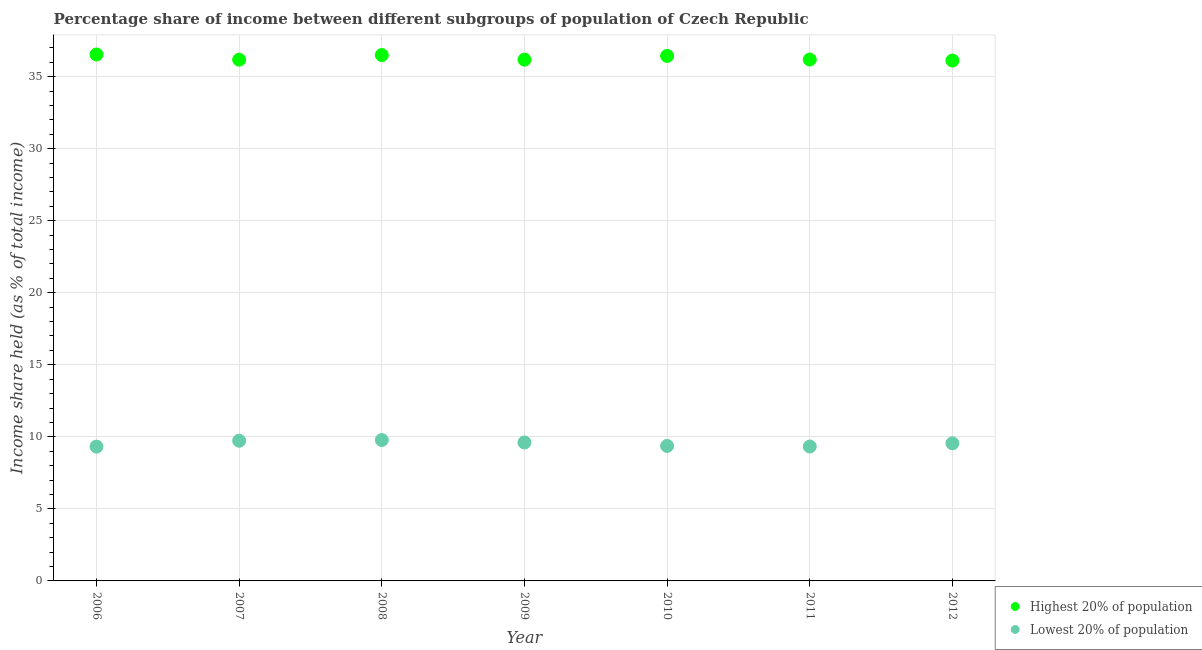Is the number of dotlines equal to the number of legend labels?
Your answer should be very brief. Yes. What is the income share held by highest 20% of the population in 2012?
Offer a terse response. 36.12. Across all years, what is the maximum income share held by lowest 20% of the population?
Keep it short and to the point. 9.78. Across all years, what is the minimum income share held by lowest 20% of the population?
Provide a short and direct response. 9.32. What is the total income share held by highest 20% of the population in the graph?
Your response must be concise. 254.15. What is the difference between the income share held by highest 20% of the population in 2007 and that in 2011?
Provide a short and direct response. -0.01. What is the difference between the income share held by highest 20% of the population in 2011 and the income share held by lowest 20% of the population in 2006?
Give a very brief answer. 26.87. What is the average income share held by highest 20% of the population per year?
Your answer should be compact. 36.31. In the year 2012, what is the difference between the income share held by highest 20% of the population and income share held by lowest 20% of the population?
Keep it short and to the point. 26.57. What is the ratio of the income share held by highest 20% of the population in 2009 to that in 2011?
Keep it short and to the point. 1. Is the difference between the income share held by lowest 20% of the population in 2011 and 2012 greater than the difference between the income share held by highest 20% of the population in 2011 and 2012?
Offer a very short reply. No. What is the difference between the highest and the second highest income share held by highest 20% of the population?
Your answer should be very brief. 0.04. What is the difference between the highest and the lowest income share held by highest 20% of the population?
Provide a short and direct response. 0.42. In how many years, is the income share held by lowest 20% of the population greater than the average income share held by lowest 20% of the population taken over all years?
Keep it short and to the point. 4. Does the income share held by highest 20% of the population monotonically increase over the years?
Ensure brevity in your answer.  No. Is the income share held by lowest 20% of the population strictly greater than the income share held by highest 20% of the population over the years?
Provide a succinct answer. No. How many dotlines are there?
Give a very brief answer. 2. How many years are there in the graph?
Give a very brief answer. 7. Are the values on the major ticks of Y-axis written in scientific E-notation?
Give a very brief answer. No. Does the graph contain any zero values?
Offer a very short reply. No. Where does the legend appear in the graph?
Provide a short and direct response. Bottom right. How many legend labels are there?
Your answer should be very brief. 2. How are the legend labels stacked?
Provide a short and direct response. Vertical. What is the title of the graph?
Provide a succinct answer. Percentage share of income between different subgroups of population of Czech Republic. Does "Electricity and heat production" appear as one of the legend labels in the graph?
Ensure brevity in your answer.  No. What is the label or title of the X-axis?
Keep it short and to the point. Year. What is the label or title of the Y-axis?
Your answer should be compact. Income share held (as % of total income). What is the Income share held (as % of total income) of Highest 20% of population in 2006?
Offer a terse response. 36.54. What is the Income share held (as % of total income) in Lowest 20% of population in 2006?
Provide a short and direct response. 9.32. What is the Income share held (as % of total income) in Highest 20% of population in 2007?
Your answer should be compact. 36.18. What is the Income share held (as % of total income) in Lowest 20% of population in 2007?
Make the answer very short. 9.73. What is the Income share held (as % of total income) in Highest 20% of population in 2008?
Provide a succinct answer. 36.5. What is the Income share held (as % of total income) in Lowest 20% of population in 2008?
Offer a terse response. 9.78. What is the Income share held (as % of total income) of Highest 20% of population in 2009?
Make the answer very short. 36.18. What is the Income share held (as % of total income) in Lowest 20% of population in 2009?
Your response must be concise. 9.61. What is the Income share held (as % of total income) in Highest 20% of population in 2010?
Offer a terse response. 36.44. What is the Income share held (as % of total income) of Lowest 20% of population in 2010?
Your answer should be compact. 9.37. What is the Income share held (as % of total income) of Highest 20% of population in 2011?
Ensure brevity in your answer.  36.19. What is the Income share held (as % of total income) in Lowest 20% of population in 2011?
Provide a succinct answer. 9.33. What is the Income share held (as % of total income) in Highest 20% of population in 2012?
Give a very brief answer. 36.12. What is the Income share held (as % of total income) in Lowest 20% of population in 2012?
Provide a succinct answer. 9.55. Across all years, what is the maximum Income share held (as % of total income) in Highest 20% of population?
Make the answer very short. 36.54. Across all years, what is the maximum Income share held (as % of total income) of Lowest 20% of population?
Provide a short and direct response. 9.78. Across all years, what is the minimum Income share held (as % of total income) in Highest 20% of population?
Your answer should be compact. 36.12. Across all years, what is the minimum Income share held (as % of total income) of Lowest 20% of population?
Your answer should be very brief. 9.32. What is the total Income share held (as % of total income) of Highest 20% of population in the graph?
Provide a succinct answer. 254.15. What is the total Income share held (as % of total income) of Lowest 20% of population in the graph?
Ensure brevity in your answer.  66.69. What is the difference between the Income share held (as % of total income) in Highest 20% of population in 2006 and that in 2007?
Make the answer very short. 0.36. What is the difference between the Income share held (as % of total income) in Lowest 20% of population in 2006 and that in 2007?
Your answer should be compact. -0.41. What is the difference between the Income share held (as % of total income) of Lowest 20% of population in 2006 and that in 2008?
Your answer should be compact. -0.46. What is the difference between the Income share held (as % of total income) of Highest 20% of population in 2006 and that in 2009?
Keep it short and to the point. 0.36. What is the difference between the Income share held (as % of total income) of Lowest 20% of population in 2006 and that in 2009?
Ensure brevity in your answer.  -0.29. What is the difference between the Income share held (as % of total income) in Lowest 20% of population in 2006 and that in 2011?
Your response must be concise. -0.01. What is the difference between the Income share held (as % of total income) in Highest 20% of population in 2006 and that in 2012?
Give a very brief answer. 0.42. What is the difference between the Income share held (as % of total income) of Lowest 20% of population in 2006 and that in 2012?
Give a very brief answer. -0.23. What is the difference between the Income share held (as % of total income) of Highest 20% of population in 2007 and that in 2008?
Keep it short and to the point. -0.32. What is the difference between the Income share held (as % of total income) of Lowest 20% of population in 2007 and that in 2008?
Keep it short and to the point. -0.05. What is the difference between the Income share held (as % of total income) of Highest 20% of population in 2007 and that in 2009?
Your answer should be very brief. 0. What is the difference between the Income share held (as % of total income) in Lowest 20% of population in 2007 and that in 2009?
Keep it short and to the point. 0.12. What is the difference between the Income share held (as % of total income) in Highest 20% of population in 2007 and that in 2010?
Offer a very short reply. -0.26. What is the difference between the Income share held (as % of total income) in Lowest 20% of population in 2007 and that in 2010?
Provide a short and direct response. 0.36. What is the difference between the Income share held (as % of total income) in Highest 20% of population in 2007 and that in 2011?
Offer a terse response. -0.01. What is the difference between the Income share held (as % of total income) in Highest 20% of population in 2007 and that in 2012?
Give a very brief answer. 0.06. What is the difference between the Income share held (as % of total income) of Lowest 20% of population in 2007 and that in 2012?
Give a very brief answer. 0.18. What is the difference between the Income share held (as % of total income) of Highest 20% of population in 2008 and that in 2009?
Your answer should be compact. 0.32. What is the difference between the Income share held (as % of total income) in Lowest 20% of population in 2008 and that in 2009?
Provide a short and direct response. 0.17. What is the difference between the Income share held (as % of total income) of Highest 20% of population in 2008 and that in 2010?
Offer a very short reply. 0.06. What is the difference between the Income share held (as % of total income) in Lowest 20% of population in 2008 and that in 2010?
Your answer should be very brief. 0.41. What is the difference between the Income share held (as % of total income) of Highest 20% of population in 2008 and that in 2011?
Provide a short and direct response. 0.31. What is the difference between the Income share held (as % of total income) in Lowest 20% of population in 2008 and that in 2011?
Give a very brief answer. 0.45. What is the difference between the Income share held (as % of total income) of Highest 20% of population in 2008 and that in 2012?
Offer a very short reply. 0.38. What is the difference between the Income share held (as % of total income) of Lowest 20% of population in 2008 and that in 2012?
Offer a terse response. 0.23. What is the difference between the Income share held (as % of total income) of Highest 20% of population in 2009 and that in 2010?
Keep it short and to the point. -0.26. What is the difference between the Income share held (as % of total income) in Lowest 20% of population in 2009 and that in 2010?
Ensure brevity in your answer.  0.24. What is the difference between the Income share held (as % of total income) in Highest 20% of population in 2009 and that in 2011?
Give a very brief answer. -0.01. What is the difference between the Income share held (as % of total income) of Lowest 20% of population in 2009 and that in 2011?
Make the answer very short. 0.28. What is the difference between the Income share held (as % of total income) of Lowest 20% of population in 2010 and that in 2011?
Offer a terse response. 0.04. What is the difference between the Income share held (as % of total income) of Highest 20% of population in 2010 and that in 2012?
Offer a very short reply. 0.32. What is the difference between the Income share held (as % of total income) in Lowest 20% of population in 2010 and that in 2012?
Make the answer very short. -0.18. What is the difference between the Income share held (as % of total income) in Highest 20% of population in 2011 and that in 2012?
Provide a succinct answer. 0.07. What is the difference between the Income share held (as % of total income) of Lowest 20% of population in 2011 and that in 2012?
Give a very brief answer. -0.22. What is the difference between the Income share held (as % of total income) in Highest 20% of population in 2006 and the Income share held (as % of total income) in Lowest 20% of population in 2007?
Your response must be concise. 26.81. What is the difference between the Income share held (as % of total income) of Highest 20% of population in 2006 and the Income share held (as % of total income) of Lowest 20% of population in 2008?
Offer a terse response. 26.76. What is the difference between the Income share held (as % of total income) in Highest 20% of population in 2006 and the Income share held (as % of total income) in Lowest 20% of population in 2009?
Give a very brief answer. 26.93. What is the difference between the Income share held (as % of total income) of Highest 20% of population in 2006 and the Income share held (as % of total income) of Lowest 20% of population in 2010?
Your answer should be very brief. 27.17. What is the difference between the Income share held (as % of total income) of Highest 20% of population in 2006 and the Income share held (as % of total income) of Lowest 20% of population in 2011?
Provide a short and direct response. 27.21. What is the difference between the Income share held (as % of total income) in Highest 20% of population in 2006 and the Income share held (as % of total income) in Lowest 20% of population in 2012?
Offer a very short reply. 26.99. What is the difference between the Income share held (as % of total income) in Highest 20% of population in 2007 and the Income share held (as % of total income) in Lowest 20% of population in 2008?
Give a very brief answer. 26.4. What is the difference between the Income share held (as % of total income) of Highest 20% of population in 2007 and the Income share held (as % of total income) of Lowest 20% of population in 2009?
Provide a short and direct response. 26.57. What is the difference between the Income share held (as % of total income) in Highest 20% of population in 2007 and the Income share held (as % of total income) in Lowest 20% of population in 2010?
Make the answer very short. 26.81. What is the difference between the Income share held (as % of total income) in Highest 20% of population in 2007 and the Income share held (as % of total income) in Lowest 20% of population in 2011?
Offer a very short reply. 26.85. What is the difference between the Income share held (as % of total income) in Highest 20% of population in 2007 and the Income share held (as % of total income) in Lowest 20% of population in 2012?
Your response must be concise. 26.63. What is the difference between the Income share held (as % of total income) of Highest 20% of population in 2008 and the Income share held (as % of total income) of Lowest 20% of population in 2009?
Make the answer very short. 26.89. What is the difference between the Income share held (as % of total income) of Highest 20% of population in 2008 and the Income share held (as % of total income) of Lowest 20% of population in 2010?
Provide a short and direct response. 27.13. What is the difference between the Income share held (as % of total income) of Highest 20% of population in 2008 and the Income share held (as % of total income) of Lowest 20% of population in 2011?
Your answer should be compact. 27.17. What is the difference between the Income share held (as % of total income) in Highest 20% of population in 2008 and the Income share held (as % of total income) in Lowest 20% of population in 2012?
Offer a terse response. 26.95. What is the difference between the Income share held (as % of total income) in Highest 20% of population in 2009 and the Income share held (as % of total income) in Lowest 20% of population in 2010?
Your response must be concise. 26.81. What is the difference between the Income share held (as % of total income) of Highest 20% of population in 2009 and the Income share held (as % of total income) of Lowest 20% of population in 2011?
Offer a terse response. 26.85. What is the difference between the Income share held (as % of total income) of Highest 20% of population in 2009 and the Income share held (as % of total income) of Lowest 20% of population in 2012?
Offer a terse response. 26.63. What is the difference between the Income share held (as % of total income) of Highest 20% of population in 2010 and the Income share held (as % of total income) of Lowest 20% of population in 2011?
Keep it short and to the point. 27.11. What is the difference between the Income share held (as % of total income) in Highest 20% of population in 2010 and the Income share held (as % of total income) in Lowest 20% of population in 2012?
Provide a succinct answer. 26.89. What is the difference between the Income share held (as % of total income) of Highest 20% of population in 2011 and the Income share held (as % of total income) of Lowest 20% of population in 2012?
Give a very brief answer. 26.64. What is the average Income share held (as % of total income) in Highest 20% of population per year?
Keep it short and to the point. 36.31. What is the average Income share held (as % of total income) of Lowest 20% of population per year?
Provide a short and direct response. 9.53. In the year 2006, what is the difference between the Income share held (as % of total income) of Highest 20% of population and Income share held (as % of total income) of Lowest 20% of population?
Offer a terse response. 27.22. In the year 2007, what is the difference between the Income share held (as % of total income) in Highest 20% of population and Income share held (as % of total income) in Lowest 20% of population?
Give a very brief answer. 26.45. In the year 2008, what is the difference between the Income share held (as % of total income) of Highest 20% of population and Income share held (as % of total income) of Lowest 20% of population?
Give a very brief answer. 26.72. In the year 2009, what is the difference between the Income share held (as % of total income) in Highest 20% of population and Income share held (as % of total income) in Lowest 20% of population?
Provide a short and direct response. 26.57. In the year 2010, what is the difference between the Income share held (as % of total income) in Highest 20% of population and Income share held (as % of total income) in Lowest 20% of population?
Give a very brief answer. 27.07. In the year 2011, what is the difference between the Income share held (as % of total income) in Highest 20% of population and Income share held (as % of total income) in Lowest 20% of population?
Provide a succinct answer. 26.86. In the year 2012, what is the difference between the Income share held (as % of total income) of Highest 20% of population and Income share held (as % of total income) of Lowest 20% of population?
Provide a short and direct response. 26.57. What is the ratio of the Income share held (as % of total income) of Lowest 20% of population in 2006 to that in 2007?
Offer a terse response. 0.96. What is the ratio of the Income share held (as % of total income) in Highest 20% of population in 2006 to that in 2008?
Offer a very short reply. 1. What is the ratio of the Income share held (as % of total income) of Lowest 20% of population in 2006 to that in 2008?
Your answer should be very brief. 0.95. What is the ratio of the Income share held (as % of total income) in Highest 20% of population in 2006 to that in 2009?
Give a very brief answer. 1.01. What is the ratio of the Income share held (as % of total income) in Lowest 20% of population in 2006 to that in 2009?
Give a very brief answer. 0.97. What is the ratio of the Income share held (as % of total income) of Lowest 20% of population in 2006 to that in 2010?
Give a very brief answer. 0.99. What is the ratio of the Income share held (as % of total income) in Highest 20% of population in 2006 to that in 2011?
Provide a succinct answer. 1.01. What is the ratio of the Income share held (as % of total income) in Highest 20% of population in 2006 to that in 2012?
Make the answer very short. 1.01. What is the ratio of the Income share held (as % of total income) in Lowest 20% of population in 2006 to that in 2012?
Ensure brevity in your answer.  0.98. What is the ratio of the Income share held (as % of total income) in Highest 20% of population in 2007 to that in 2009?
Offer a terse response. 1. What is the ratio of the Income share held (as % of total income) in Lowest 20% of population in 2007 to that in 2009?
Your response must be concise. 1.01. What is the ratio of the Income share held (as % of total income) of Lowest 20% of population in 2007 to that in 2010?
Ensure brevity in your answer.  1.04. What is the ratio of the Income share held (as % of total income) in Lowest 20% of population in 2007 to that in 2011?
Ensure brevity in your answer.  1.04. What is the ratio of the Income share held (as % of total income) in Highest 20% of population in 2007 to that in 2012?
Provide a succinct answer. 1. What is the ratio of the Income share held (as % of total income) of Lowest 20% of population in 2007 to that in 2012?
Provide a short and direct response. 1.02. What is the ratio of the Income share held (as % of total income) of Highest 20% of population in 2008 to that in 2009?
Keep it short and to the point. 1.01. What is the ratio of the Income share held (as % of total income) of Lowest 20% of population in 2008 to that in 2009?
Offer a terse response. 1.02. What is the ratio of the Income share held (as % of total income) of Highest 20% of population in 2008 to that in 2010?
Your answer should be compact. 1. What is the ratio of the Income share held (as % of total income) of Lowest 20% of population in 2008 to that in 2010?
Your answer should be compact. 1.04. What is the ratio of the Income share held (as % of total income) in Highest 20% of population in 2008 to that in 2011?
Provide a succinct answer. 1.01. What is the ratio of the Income share held (as % of total income) of Lowest 20% of population in 2008 to that in 2011?
Provide a short and direct response. 1.05. What is the ratio of the Income share held (as % of total income) in Highest 20% of population in 2008 to that in 2012?
Ensure brevity in your answer.  1.01. What is the ratio of the Income share held (as % of total income) of Lowest 20% of population in 2008 to that in 2012?
Offer a very short reply. 1.02. What is the ratio of the Income share held (as % of total income) of Lowest 20% of population in 2009 to that in 2010?
Provide a succinct answer. 1.03. What is the ratio of the Income share held (as % of total income) in Lowest 20% of population in 2009 to that in 2011?
Your response must be concise. 1.03. What is the ratio of the Income share held (as % of total income) in Lowest 20% of population in 2009 to that in 2012?
Your answer should be very brief. 1.01. What is the ratio of the Income share held (as % of total income) in Highest 20% of population in 2010 to that in 2011?
Ensure brevity in your answer.  1.01. What is the ratio of the Income share held (as % of total income) in Highest 20% of population in 2010 to that in 2012?
Your answer should be compact. 1.01. What is the ratio of the Income share held (as % of total income) of Lowest 20% of population in 2010 to that in 2012?
Give a very brief answer. 0.98. What is the ratio of the Income share held (as % of total income) in Highest 20% of population in 2011 to that in 2012?
Your answer should be very brief. 1. What is the difference between the highest and the second highest Income share held (as % of total income) in Lowest 20% of population?
Keep it short and to the point. 0.05. What is the difference between the highest and the lowest Income share held (as % of total income) in Highest 20% of population?
Your answer should be very brief. 0.42. What is the difference between the highest and the lowest Income share held (as % of total income) of Lowest 20% of population?
Your response must be concise. 0.46. 